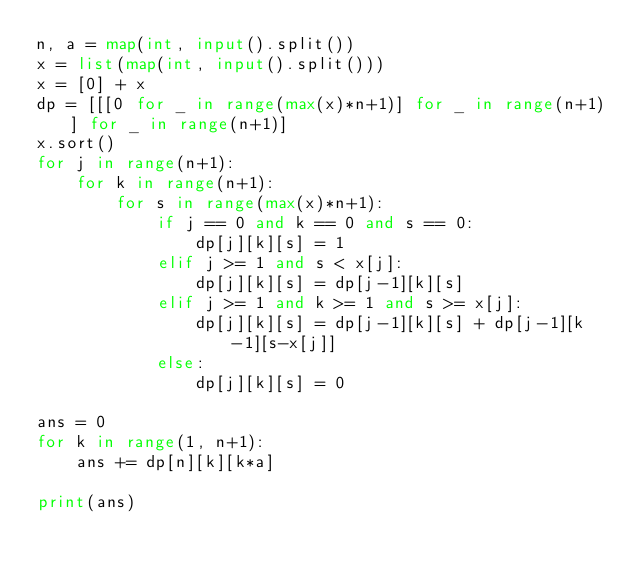Convert code to text. <code><loc_0><loc_0><loc_500><loc_500><_Python_>n, a = map(int, input().split())
x = list(map(int, input().split()))
x = [0] + x
dp = [[[0 for _ in range(max(x)*n+1)] for _ in range(n+1)] for _ in range(n+1)]
x.sort()
for j in range(n+1):
    for k in range(n+1):
        for s in range(max(x)*n+1):
            if j == 0 and k == 0 and s == 0:
                dp[j][k][s] = 1
            elif j >= 1 and s < x[j]:
                dp[j][k][s] = dp[j-1][k][s]
            elif j >= 1 and k >= 1 and s >= x[j]:
                dp[j][k][s] = dp[j-1][k][s] + dp[j-1][k-1][s-x[j]]
            else:
                dp[j][k][s] = 0

ans = 0
for k in range(1, n+1):
    ans += dp[n][k][k*a]

print(ans)</code> 